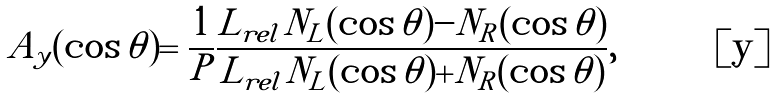<formula> <loc_0><loc_0><loc_500><loc_500>A _ { y } ( \cos \theta ) = \frac { 1 } { P } \frac { L _ { r e l } N _ { L } ( \cos \theta ) - N _ { R } ( \cos \theta ) } { L _ { r e l } N _ { L } ( \cos \theta ) + N _ { R } ( \cos \theta ) } ,</formula> 